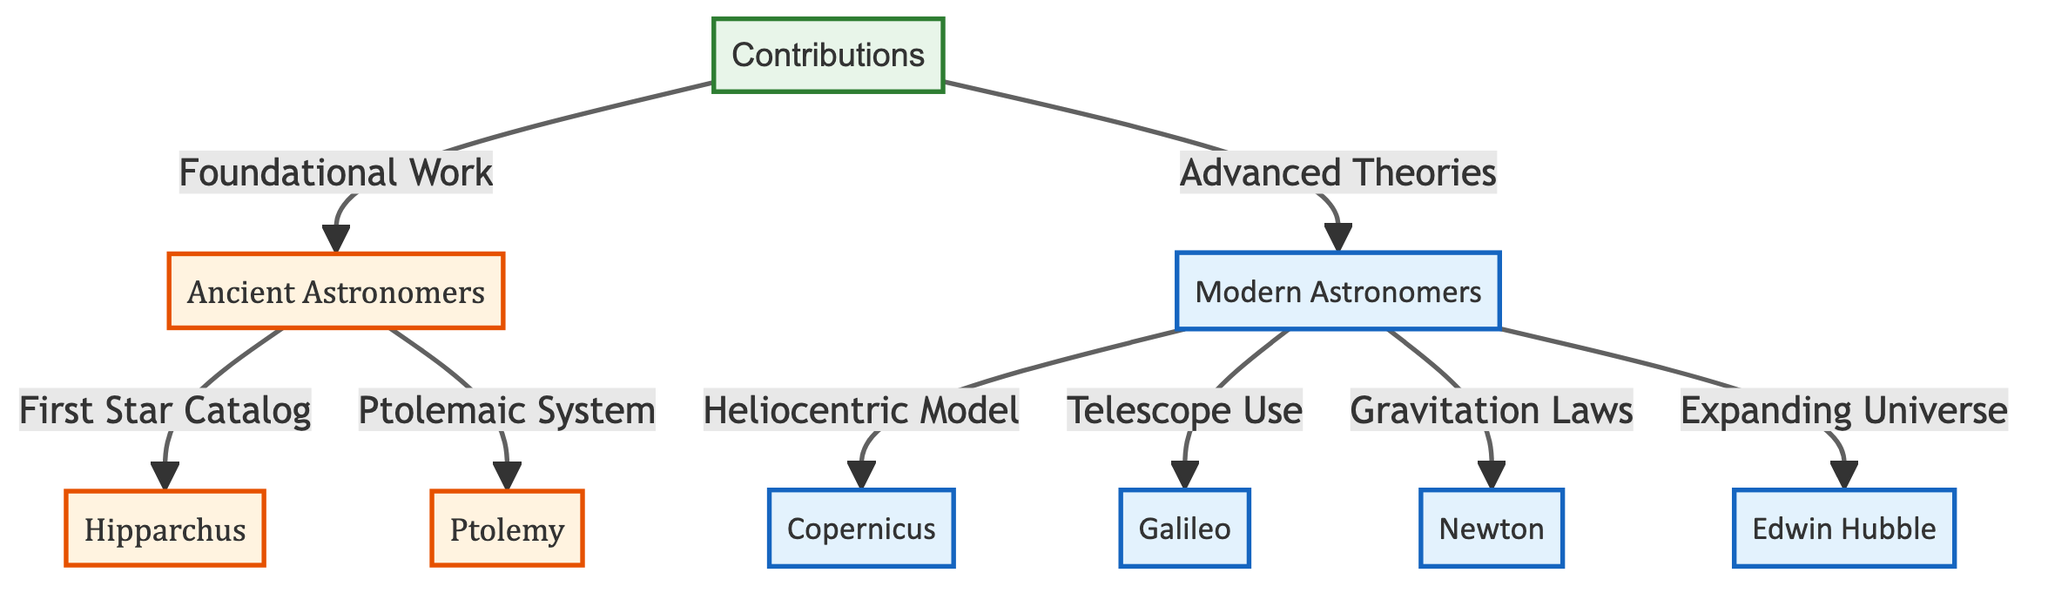What are the two categories of astronomers identified in the diagram? The diagram has two main categories labeled as "Ancient Astronomers" and "Modern Astronomers." These are directly connected to the "Contributions" node, indicating the two eras of contributions outlined in the diagram.
Answer: Ancient Astronomers, Modern Astronomers How many ancient astronomers are listed in the diagram? The diagram lists two ancient astronomers: Hipparchus and Ptolemy. Each is connected to the "Ancient Astronomers" node, showing their contributions in this category.
Answer: 2 What contribution is connected to Copernicus? The connection shows that Copernicus contributed to the "Heliocentric Model." This is a direct relationship indicated within the "Modern Astronomers" category.
Answer: Heliocentric Model Which astronomer is associated with the concept of an "Expanding Universe"? Edwin Hubble is linked to the "Expanding Universe" contribution in the "Modern Astronomers" section of the diagram, indicating his pivotal role in this understanding.
Answer: Edwin Hubble What foundational work is attributed to Hipparchus? The diagram connects Hipparchus to the "First Star Catalog," highlighting his significant role in the early documentation of stars.
Answer: First Star Catalog How many contributions are associated with modern astronomers? The diagram shows four key contributions associated with modern astronomers: Heliocentric Model, Telescope Use, Gravitation Laws, and Expanding Universe. These contributions come under the "Advanced Theories" category tied to modern astronomers.
Answer: 4 Which ancient astronomer created the Ptolemaic System? Ptolemy is identified in the diagram as the ancient astronomer responsible for the "Ptolemaic System," a geocentric model of the universe that was widely accepted before the heliocentric model.
Answer: Ptolemy What is the relationship between modern and ancient astronomers in this diagram? The diagram illustrates that both ancient and modern astronomers contribute significantly to humanity's understanding of the universe, with ancient astronomers providing foundational work that modern astronomers built upon with advanced theories.
Answer: Foundational vs. Advanced Theories 